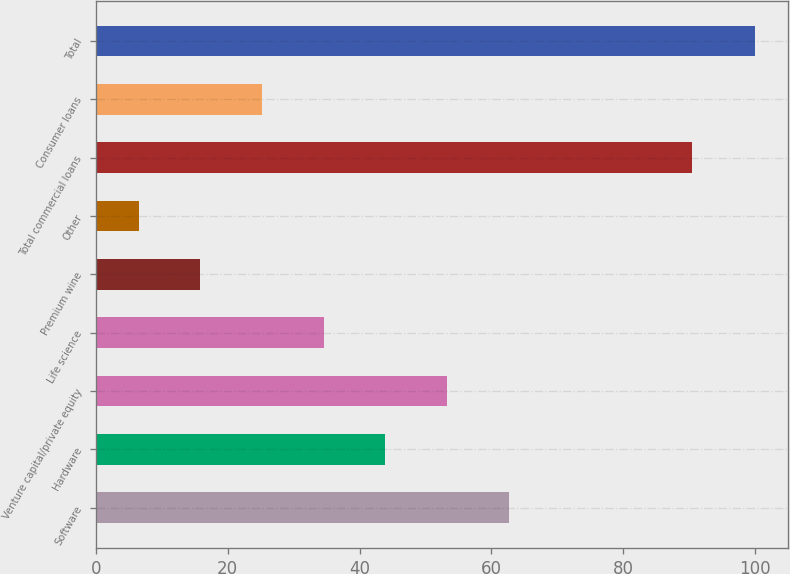Convert chart. <chart><loc_0><loc_0><loc_500><loc_500><bar_chart><fcel>Software<fcel>Hardware<fcel>Venture capital/private equity<fcel>Life science<fcel>Premium wine<fcel>Other<fcel>Total commercial loans<fcel>Consumer loans<fcel>Total<nl><fcel>62.6<fcel>43.9<fcel>53.25<fcel>34.55<fcel>15.85<fcel>6.5<fcel>90.4<fcel>25.2<fcel>100<nl></chart> 